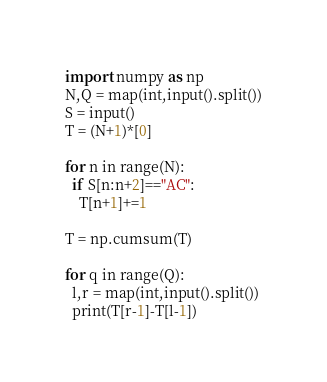Convert code to text. <code><loc_0><loc_0><loc_500><loc_500><_Python_>import numpy as np
N,Q = map(int,input().split())
S = input()
T = (N+1)*[0]

for n in range(N):
  if S[n:n+2]=="AC":
    T[n+1]+=1

T = np.cumsum(T)

for q in range(Q):
  l,r = map(int,input().split())
  print(T[r-1]-T[l-1])</code> 